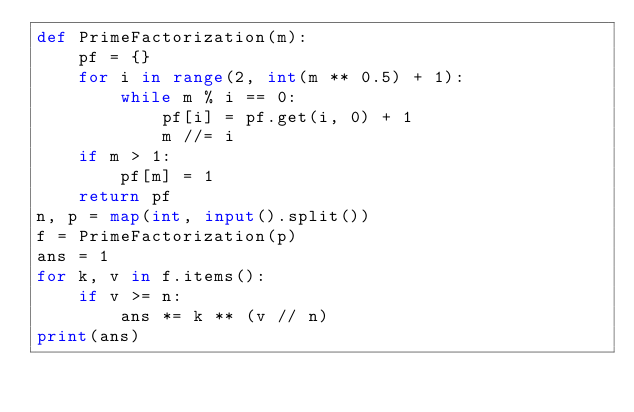Convert code to text. <code><loc_0><loc_0><loc_500><loc_500><_Python_>def PrimeFactorization(m):
    pf = {}
    for i in range(2, int(m ** 0.5) + 1):
        while m % i == 0:
            pf[i] = pf.get(i, 0) + 1
            m //= i
    if m > 1:
        pf[m] = 1
    return pf
n, p = map(int, input().split())
f = PrimeFactorization(p)
ans = 1
for k, v in f.items():
    if v >= n:
        ans *= k ** (v // n)
print(ans)</code> 